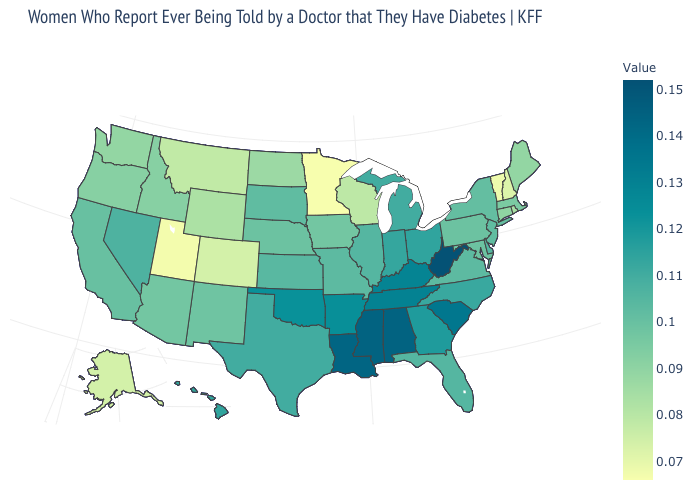Is the legend a continuous bar?
Be succinct. Yes. Does the map have missing data?
Be succinct. No. Does West Virginia have the highest value in the USA?
Keep it brief. Yes. 